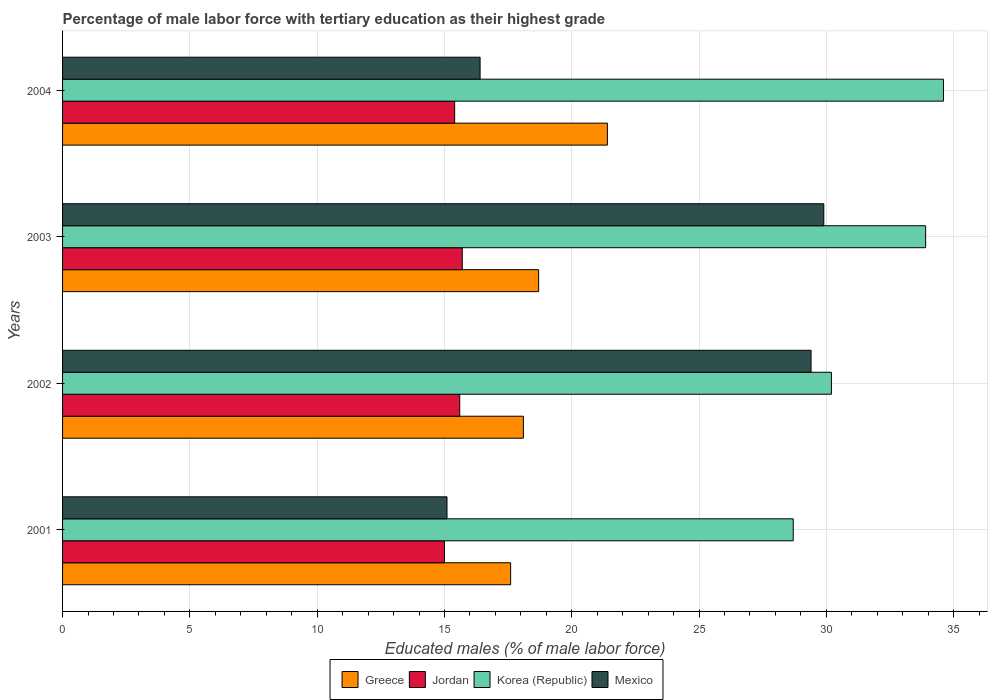How many groups of bars are there?
Keep it short and to the point. 4. Are the number of bars per tick equal to the number of legend labels?
Keep it short and to the point. Yes. Are the number of bars on each tick of the Y-axis equal?
Your response must be concise. Yes. How many bars are there on the 1st tick from the bottom?
Your answer should be compact. 4. In how many cases, is the number of bars for a given year not equal to the number of legend labels?
Offer a terse response. 0. What is the percentage of male labor force with tertiary education in Jordan in 2002?
Offer a terse response. 15.6. Across all years, what is the maximum percentage of male labor force with tertiary education in Mexico?
Ensure brevity in your answer.  29.9. Across all years, what is the minimum percentage of male labor force with tertiary education in Jordan?
Offer a very short reply. 15. In which year was the percentage of male labor force with tertiary education in Mexico minimum?
Provide a succinct answer. 2001. What is the total percentage of male labor force with tertiary education in Greece in the graph?
Provide a short and direct response. 75.8. What is the difference between the percentage of male labor force with tertiary education in Korea (Republic) in 2004 and the percentage of male labor force with tertiary education in Greece in 2003?
Ensure brevity in your answer.  15.9. What is the average percentage of male labor force with tertiary education in Mexico per year?
Offer a terse response. 22.7. In the year 2002, what is the difference between the percentage of male labor force with tertiary education in Jordan and percentage of male labor force with tertiary education in Mexico?
Provide a short and direct response. -13.8. What is the ratio of the percentage of male labor force with tertiary education in Korea (Republic) in 2001 to that in 2003?
Provide a succinct answer. 0.85. Is the percentage of male labor force with tertiary education in Greece in 2002 less than that in 2004?
Your response must be concise. Yes. Is the difference between the percentage of male labor force with tertiary education in Jordan in 2002 and 2004 greater than the difference between the percentage of male labor force with tertiary education in Mexico in 2002 and 2004?
Provide a succinct answer. No. What is the difference between the highest and the second highest percentage of male labor force with tertiary education in Korea (Republic)?
Offer a terse response. 0.7. What is the difference between the highest and the lowest percentage of male labor force with tertiary education in Jordan?
Offer a terse response. 0.7. In how many years, is the percentage of male labor force with tertiary education in Jordan greater than the average percentage of male labor force with tertiary education in Jordan taken over all years?
Your answer should be compact. 2. Are all the bars in the graph horizontal?
Offer a very short reply. Yes. What is the difference between two consecutive major ticks on the X-axis?
Keep it short and to the point. 5. Does the graph contain any zero values?
Your answer should be compact. No. Where does the legend appear in the graph?
Keep it short and to the point. Bottom center. How many legend labels are there?
Ensure brevity in your answer.  4. What is the title of the graph?
Make the answer very short. Percentage of male labor force with tertiary education as their highest grade. Does "Latvia" appear as one of the legend labels in the graph?
Give a very brief answer. No. What is the label or title of the X-axis?
Make the answer very short. Educated males (% of male labor force). What is the Educated males (% of male labor force) of Greece in 2001?
Offer a terse response. 17.6. What is the Educated males (% of male labor force) of Jordan in 2001?
Give a very brief answer. 15. What is the Educated males (% of male labor force) in Korea (Republic) in 2001?
Your answer should be compact. 28.7. What is the Educated males (% of male labor force) in Mexico in 2001?
Ensure brevity in your answer.  15.1. What is the Educated males (% of male labor force) of Greece in 2002?
Ensure brevity in your answer.  18.1. What is the Educated males (% of male labor force) of Jordan in 2002?
Provide a succinct answer. 15.6. What is the Educated males (% of male labor force) of Korea (Republic) in 2002?
Give a very brief answer. 30.2. What is the Educated males (% of male labor force) of Mexico in 2002?
Offer a very short reply. 29.4. What is the Educated males (% of male labor force) of Greece in 2003?
Keep it short and to the point. 18.7. What is the Educated males (% of male labor force) in Jordan in 2003?
Offer a very short reply. 15.7. What is the Educated males (% of male labor force) in Korea (Republic) in 2003?
Your answer should be compact. 33.9. What is the Educated males (% of male labor force) of Mexico in 2003?
Provide a short and direct response. 29.9. What is the Educated males (% of male labor force) in Greece in 2004?
Provide a short and direct response. 21.4. What is the Educated males (% of male labor force) of Jordan in 2004?
Provide a succinct answer. 15.4. What is the Educated males (% of male labor force) of Korea (Republic) in 2004?
Offer a terse response. 34.6. What is the Educated males (% of male labor force) in Mexico in 2004?
Provide a short and direct response. 16.4. Across all years, what is the maximum Educated males (% of male labor force) in Greece?
Your answer should be compact. 21.4. Across all years, what is the maximum Educated males (% of male labor force) of Jordan?
Provide a short and direct response. 15.7. Across all years, what is the maximum Educated males (% of male labor force) in Korea (Republic)?
Provide a succinct answer. 34.6. Across all years, what is the maximum Educated males (% of male labor force) in Mexico?
Give a very brief answer. 29.9. Across all years, what is the minimum Educated males (% of male labor force) in Greece?
Keep it short and to the point. 17.6. Across all years, what is the minimum Educated males (% of male labor force) in Korea (Republic)?
Offer a very short reply. 28.7. Across all years, what is the minimum Educated males (% of male labor force) in Mexico?
Make the answer very short. 15.1. What is the total Educated males (% of male labor force) of Greece in the graph?
Your answer should be very brief. 75.8. What is the total Educated males (% of male labor force) of Jordan in the graph?
Provide a succinct answer. 61.7. What is the total Educated males (% of male labor force) of Korea (Republic) in the graph?
Your answer should be very brief. 127.4. What is the total Educated males (% of male labor force) of Mexico in the graph?
Offer a terse response. 90.8. What is the difference between the Educated males (% of male labor force) of Greece in 2001 and that in 2002?
Offer a terse response. -0.5. What is the difference between the Educated males (% of male labor force) of Jordan in 2001 and that in 2002?
Keep it short and to the point. -0.6. What is the difference between the Educated males (% of male labor force) of Korea (Republic) in 2001 and that in 2002?
Provide a succinct answer. -1.5. What is the difference between the Educated males (% of male labor force) in Mexico in 2001 and that in 2002?
Offer a terse response. -14.3. What is the difference between the Educated males (% of male labor force) in Mexico in 2001 and that in 2003?
Offer a very short reply. -14.8. What is the difference between the Educated males (% of male labor force) of Greece in 2001 and that in 2004?
Give a very brief answer. -3.8. What is the difference between the Educated males (% of male labor force) of Jordan in 2001 and that in 2004?
Offer a very short reply. -0.4. What is the difference between the Educated males (% of male labor force) of Greece in 2002 and that in 2004?
Make the answer very short. -3.3. What is the difference between the Educated males (% of male labor force) in Mexico in 2002 and that in 2004?
Provide a succinct answer. 13. What is the difference between the Educated males (% of male labor force) of Jordan in 2003 and that in 2004?
Offer a very short reply. 0.3. What is the difference between the Educated males (% of male labor force) in Mexico in 2003 and that in 2004?
Provide a succinct answer. 13.5. What is the difference between the Educated males (% of male labor force) of Greece in 2001 and the Educated males (% of male labor force) of Jordan in 2002?
Make the answer very short. 2. What is the difference between the Educated males (% of male labor force) in Greece in 2001 and the Educated males (% of male labor force) in Mexico in 2002?
Your response must be concise. -11.8. What is the difference between the Educated males (% of male labor force) in Jordan in 2001 and the Educated males (% of male labor force) in Korea (Republic) in 2002?
Offer a terse response. -15.2. What is the difference between the Educated males (% of male labor force) in Jordan in 2001 and the Educated males (% of male labor force) in Mexico in 2002?
Keep it short and to the point. -14.4. What is the difference between the Educated males (% of male labor force) in Korea (Republic) in 2001 and the Educated males (% of male labor force) in Mexico in 2002?
Offer a terse response. -0.7. What is the difference between the Educated males (% of male labor force) in Greece in 2001 and the Educated males (% of male labor force) in Korea (Republic) in 2003?
Your answer should be compact. -16.3. What is the difference between the Educated males (% of male labor force) in Greece in 2001 and the Educated males (% of male labor force) in Mexico in 2003?
Provide a succinct answer. -12.3. What is the difference between the Educated males (% of male labor force) of Jordan in 2001 and the Educated males (% of male labor force) of Korea (Republic) in 2003?
Make the answer very short. -18.9. What is the difference between the Educated males (% of male labor force) in Jordan in 2001 and the Educated males (% of male labor force) in Mexico in 2003?
Your response must be concise. -14.9. What is the difference between the Educated males (% of male labor force) of Greece in 2001 and the Educated males (% of male labor force) of Jordan in 2004?
Provide a short and direct response. 2.2. What is the difference between the Educated males (% of male labor force) of Greece in 2001 and the Educated males (% of male labor force) of Korea (Republic) in 2004?
Your response must be concise. -17. What is the difference between the Educated males (% of male labor force) of Greece in 2001 and the Educated males (% of male labor force) of Mexico in 2004?
Make the answer very short. 1.2. What is the difference between the Educated males (% of male labor force) of Jordan in 2001 and the Educated males (% of male labor force) of Korea (Republic) in 2004?
Offer a very short reply. -19.6. What is the difference between the Educated males (% of male labor force) in Greece in 2002 and the Educated males (% of male labor force) in Jordan in 2003?
Provide a short and direct response. 2.4. What is the difference between the Educated males (% of male labor force) in Greece in 2002 and the Educated males (% of male labor force) in Korea (Republic) in 2003?
Offer a very short reply. -15.8. What is the difference between the Educated males (% of male labor force) of Jordan in 2002 and the Educated males (% of male labor force) of Korea (Republic) in 2003?
Your answer should be compact. -18.3. What is the difference between the Educated males (% of male labor force) of Jordan in 2002 and the Educated males (% of male labor force) of Mexico in 2003?
Your answer should be very brief. -14.3. What is the difference between the Educated males (% of male labor force) of Greece in 2002 and the Educated males (% of male labor force) of Korea (Republic) in 2004?
Your answer should be very brief. -16.5. What is the difference between the Educated males (% of male labor force) in Korea (Republic) in 2002 and the Educated males (% of male labor force) in Mexico in 2004?
Give a very brief answer. 13.8. What is the difference between the Educated males (% of male labor force) in Greece in 2003 and the Educated males (% of male labor force) in Jordan in 2004?
Your answer should be very brief. 3.3. What is the difference between the Educated males (% of male labor force) of Greece in 2003 and the Educated males (% of male labor force) of Korea (Republic) in 2004?
Ensure brevity in your answer.  -15.9. What is the difference between the Educated males (% of male labor force) in Greece in 2003 and the Educated males (% of male labor force) in Mexico in 2004?
Your answer should be very brief. 2.3. What is the difference between the Educated males (% of male labor force) of Jordan in 2003 and the Educated males (% of male labor force) of Korea (Republic) in 2004?
Offer a very short reply. -18.9. What is the average Educated males (% of male labor force) of Greece per year?
Ensure brevity in your answer.  18.95. What is the average Educated males (% of male labor force) of Jordan per year?
Offer a terse response. 15.43. What is the average Educated males (% of male labor force) in Korea (Republic) per year?
Ensure brevity in your answer.  31.85. What is the average Educated males (% of male labor force) of Mexico per year?
Your answer should be compact. 22.7. In the year 2001, what is the difference between the Educated males (% of male labor force) of Greece and Educated males (% of male labor force) of Jordan?
Provide a succinct answer. 2.6. In the year 2001, what is the difference between the Educated males (% of male labor force) in Jordan and Educated males (% of male labor force) in Korea (Republic)?
Ensure brevity in your answer.  -13.7. In the year 2001, what is the difference between the Educated males (% of male labor force) in Jordan and Educated males (% of male labor force) in Mexico?
Offer a terse response. -0.1. In the year 2001, what is the difference between the Educated males (% of male labor force) of Korea (Republic) and Educated males (% of male labor force) of Mexico?
Your answer should be compact. 13.6. In the year 2002, what is the difference between the Educated males (% of male labor force) in Greece and Educated males (% of male labor force) in Jordan?
Your response must be concise. 2.5. In the year 2002, what is the difference between the Educated males (% of male labor force) in Jordan and Educated males (% of male labor force) in Korea (Republic)?
Ensure brevity in your answer.  -14.6. In the year 2002, what is the difference between the Educated males (% of male labor force) in Jordan and Educated males (% of male labor force) in Mexico?
Offer a terse response. -13.8. In the year 2003, what is the difference between the Educated males (% of male labor force) of Greece and Educated males (% of male labor force) of Jordan?
Provide a succinct answer. 3. In the year 2003, what is the difference between the Educated males (% of male labor force) of Greece and Educated males (% of male labor force) of Korea (Republic)?
Offer a terse response. -15.2. In the year 2003, what is the difference between the Educated males (% of male labor force) in Jordan and Educated males (% of male labor force) in Korea (Republic)?
Provide a succinct answer. -18.2. In the year 2003, what is the difference between the Educated males (% of male labor force) of Korea (Republic) and Educated males (% of male labor force) of Mexico?
Provide a short and direct response. 4. In the year 2004, what is the difference between the Educated males (% of male labor force) of Jordan and Educated males (% of male labor force) of Korea (Republic)?
Make the answer very short. -19.2. What is the ratio of the Educated males (% of male labor force) in Greece in 2001 to that in 2002?
Make the answer very short. 0.97. What is the ratio of the Educated males (% of male labor force) of Jordan in 2001 to that in 2002?
Ensure brevity in your answer.  0.96. What is the ratio of the Educated males (% of male labor force) in Korea (Republic) in 2001 to that in 2002?
Ensure brevity in your answer.  0.95. What is the ratio of the Educated males (% of male labor force) in Mexico in 2001 to that in 2002?
Offer a very short reply. 0.51. What is the ratio of the Educated males (% of male labor force) of Greece in 2001 to that in 2003?
Your answer should be very brief. 0.94. What is the ratio of the Educated males (% of male labor force) in Jordan in 2001 to that in 2003?
Offer a terse response. 0.96. What is the ratio of the Educated males (% of male labor force) of Korea (Republic) in 2001 to that in 2003?
Your answer should be very brief. 0.85. What is the ratio of the Educated males (% of male labor force) of Mexico in 2001 to that in 2003?
Your answer should be very brief. 0.51. What is the ratio of the Educated males (% of male labor force) of Greece in 2001 to that in 2004?
Your answer should be very brief. 0.82. What is the ratio of the Educated males (% of male labor force) of Korea (Republic) in 2001 to that in 2004?
Your response must be concise. 0.83. What is the ratio of the Educated males (% of male labor force) in Mexico in 2001 to that in 2004?
Your response must be concise. 0.92. What is the ratio of the Educated males (% of male labor force) of Greece in 2002 to that in 2003?
Provide a short and direct response. 0.97. What is the ratio of the Educated males (% of male labor force) of Korea (Republic) in 2002 to that in 2003?
Keep it short and to the point. 0.89. What is the ratio of the Educated males (% of male labor force) in Mexico in 2002 to that in 2003?
Offer a very short reply. 0.98. What is the ratio of the Educated males (% of male labor force) of Greece in 2002 to that in 2004?
Your response must be concise. 0.85. What is the ratio of the Educated males (% of male labor force) in Jordan in 2002 to that in 2004?
Provide a succinct answer. 1.01. What is the ratio of the Educated males (% of male labor force) in Korea (Republic) in 2002 to that in 2004?
Provide a succinct answer. 0.87. What is the ratio of the Educated males (% of male labor force) in Mexico in 2002 to that in 2004?
Keep it short and to the point. 1.79. What is the ratio of the Educated males (% of male labor force) in Greece in 2003 to that in 2004?
Ensure brevity in your answer.  0.87. What is the ratio of the Educated males (% of male labor force) of Jordan in 2003 to that in 2004?
Keep it short and to the point. 1.02. What is the ratio of the Educated males (% of male labor force) in Korea (Republic) in 2003 to that in 2004?
Your answer should be very brief. 0.98. What is the ratio of the Educated males (% of male labor force) of Mexico in 2003 to that in 2004?
Ensure brevity in your answer.  1.82. What is the difference between the highest and the second highest Educated males (% of male labor force) of Korea (Republic)?
Your answer should be compact. 0.7. What is the difference between the highest and the second highest Educated males (% of male labor force) in Mexico?
Provide a succinct answer. 0.5. What is the difference between the highest and the lowest Educated males (% of male labor force) in Jordan?
Offer a very short reply. 0.7. What is the difference between the highest and the lowest Educated males (% of male labor force) of Korea (Republic)?
Ensure brevity in your answer.  5.9. 